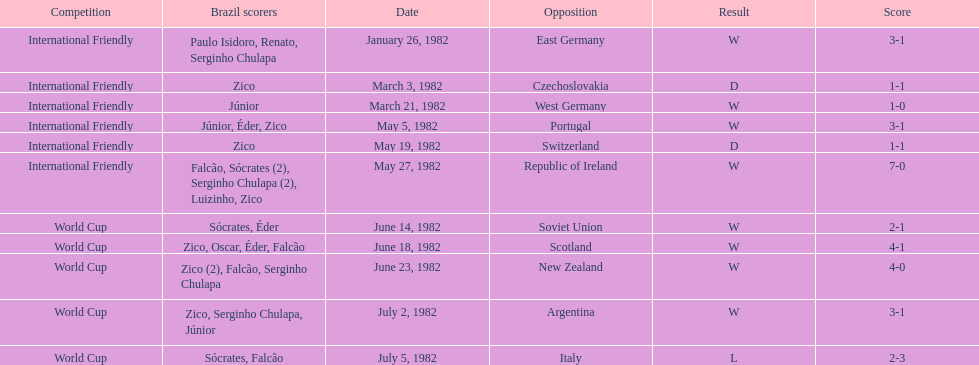Was the total goals scored on june 14, 1982 more than 6? No. 